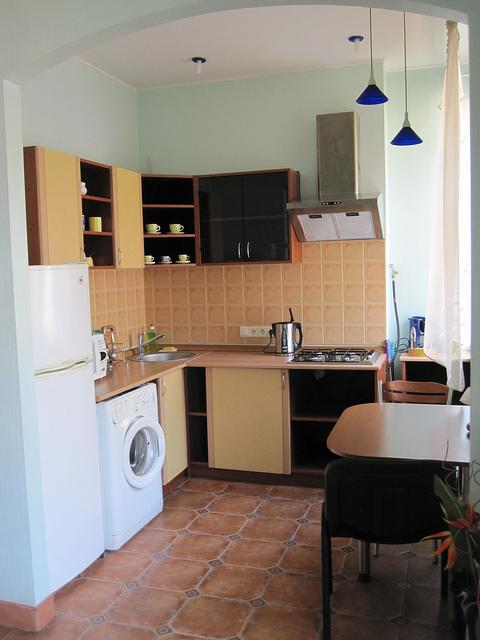What is the small white appliance? microwave 